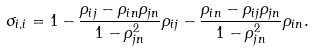Convert formula to latex. <formula><loc_0><loc_0><loc_500><loc_500>\sigma _ { i , i } = 1 - \frac { \rho _ { i j } - \rho _ { i n } \rho _ { j n } } { 1 - \rho _ { j n } ^ { 2 } } \rho _ { i j } - \frac { \rho _ { i n } - \rho _ { i j } \rho _ { j n } } { 1 - \rho _ { j n } ^ { 2 } } \rho _ { i n } .</formula> 